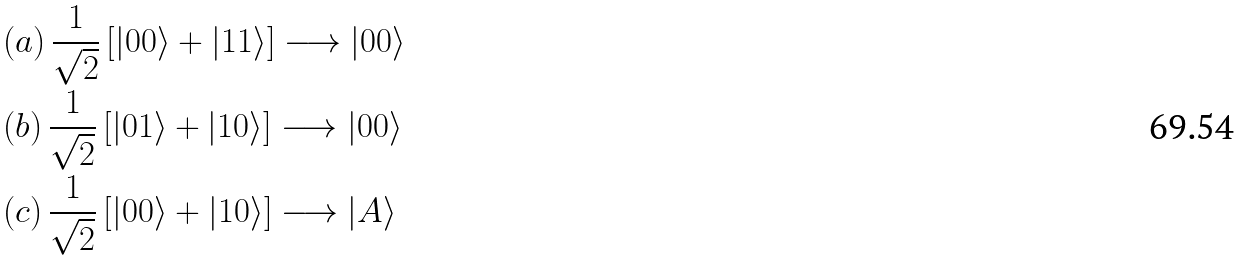Convert formula to latex. <formula><loc_0><loc_0><loc_500><loc_500>& ( a ) \, \frac { 1 } { \sqrt { 2 } } \left [ | 0 0 \rangle + | 1 1 \rangle \right ] \longrightarrow | 0 0 \rangle \\ & ( b ) \, \frac { 1 } { \sqrt { 2 } } \left [ | 0 1 \rangle + | 1 0 \rangle \right ] \longrightarrow | 0 0 \rangle \\ & ( c ) \, \frac { 1 } { \sqrt { 2 } } \left [ | 0 0 \rangle + | 1 0 \rangle \right ] \longrightarrow | A \rangle</formula> 